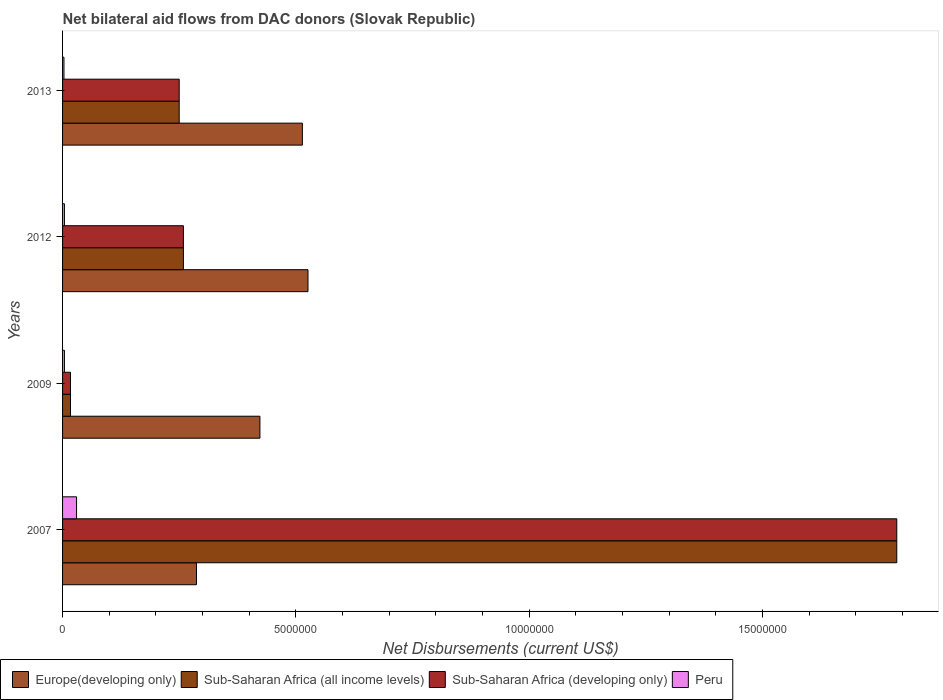How many different coloured bars are there?
Give a very brief answer. 4. Are the number of bars per tick equal to the number of legend labels?
Provide a succinct answer. Yes. Are the number of bars on each tick of the Y-axis equal?
Offer a very short reply. Yes. How many bars are there on the 4th tick from the bottom?
Offer a very short reply. 4. What is the label of the 1st group of bars from the top?
Your response must be concise. 2013. In how many cases, is the number of bars for a given year not equal to the number of legend labels?
Make the answer very short. 0. What is the net bilateral aid flows in Sub-Saharan Africa (developing only) in 2013?
Keep it short and to the point. 2.50e+06. Across all years, what is the minimum net bilateral aid flows in Sub-Saharan Africa (all income levels)?
Make the answer very short. 1.70e+05. In which year was the net bilateral aid flows in Sub-Saharan Africa (developing only) minimum?
Offer a terse response. 2009. What is the difference between the net bilateral aid flows in Sub-Saharan Africa (all income levels) in 2007 and that in 2009?
Give a very brief answer. 1.77e+07. What is the difference between the net bilateral aid flows in Sub-Saharan Africa (developing only) in 2009 and the net bilateral aid flows in Europe(developing only) in 2012?
Provide a short and direct response. -5.09e+06. What is the average net bilateral aid flows in Sub-Saharan Africa (all income levels) per year?
Provide a succinct answer. 5.78e+06. In the year 2012, what is the difference between the net bilateral aid flows in Europe(developing only) and net bilateral aid flows in Sub-Saharan Africa (developing only)?
Ensure brevity in your answer.  2.67e+06. In how many years, is the net bilateral aid flows in Europe(developing only) greater than 10000000 US$?
Ensure brevity in your answer.  0. What is the ratio of the net bilateral aid flows in Peru in 2012 to that in 2013?
Your response must be concise. 1.33. Is the difference between the net bilateral aid flows in Europe(developing only) in 2009 and 2012 greater than the difference between the net bilateral aid flows in Sub-Saharan Africa (developing only) in 2009 and 2012?
Provide a short and direct response. Yes. What is the difference between the highest and the second highest net bilateral aid flows in Sub-Saharan Africa (developing only)?
Your answer should be compact. 1.53e+07. What does the 3rd bar from the top in 2007 represents?
Your response must be concise. Sub-Saharan Africa (all income levels). What does the 2nd bar from the bottom in 2012 represents?
Offer a terse response. Sub-Saharan Africa (all income levels). Is it the case that in every year, the sum of the net bilateral aid flows in Sub-Saharan Africa (developing only) and net bilateral aid flows in Europe(developing only) is greater than the net bilateral aid flows in Sub-Saharan Africa (all income levels)?
Offer a terse response. Yes. Are all the bars in the graph horizontal?
Your answer should be very brief. Yes. What is the difference between two consecutive major ticks on the X-axis?
Provide a succinct answer. 5.00e+06. Where does the legend appear in the graph?
Your response must be concise. Bottom left. How many legend labels are there?
Your answer should be compact. 4. What is the title of the graph?
Your answer should be very brief. Net bilateral aid flows from DAC donors (Slovak Republic). What is the label or title of the X-axis?
Keep it short and to the point. Net Disbursements (current US$). What is the Net Disbursements (current US$) of Europe(developing only) in 2007?
Ensure brevity in your answer.  2.87e+06. What is the Net Disbursements (current US$) of Sub-Saharan Africa (all income levels) in 2007?
Your response must be concise. 1.79e+07. What is the Net Disbursements (current US$) of Sub-Saharan Africa (developing only) in 2007?
Offer a very short reply. 1.79e+07. What is the Net Disbursements (current US$) of Europe(developing only) in 2009?
Provide a succinct answer. 4.23e+06. What is the Net Disbursements (current US$) of Sub-Saharan Africa (all income levels) in 2009?
Make the answer very short. 1.70e+05. What is the Net Disbursements (current US$) in Sub-Saharan Africa (developing only) in 2009?
Your response must be concise. 1.70e+05. What is the Net Disbursements (current US$) of Peru in 2009?
Keep it short and to the point. 4.00e+04. What is the Net Disbursements (current US$) of Europe(developing only) in 2012?
Offer a very short reply. 5.26e+06. What is the Net Disbursements (current US$) in Sub-Saharan Africa (all income levels) in 2012?
Your answer should be compact. 2.59e+06. What is the Net Disbursements (current US$) in Sub-Saharan Africa (developing only) in 2012?
Offer a very short reply. 2.59e+06. What is the Net Disbursements (current US$) of Peru in 2012?
Make the answer very short. 4.00e+04. What is the Net Disbursements (current US$) of Europe(developing only) in 2013?
Keep it short and to the point. 5.14e+06. What is the Net Disbursements (current US$) in Sub-Saharan Africa (all income levels) in 2013?
Give a very brief answer. 2.50e+06. What is the Net Disbursements (current US$) of Sub-Saharan Africa (developing only) in 2013?
Your response must be concise. 2.50e+06. Across all years, what is the maximum Net Disbursements (current US$) in Europe(developing only)?
Your response must be concise. 5.26e+06. Across all years, what is the maximum Net Disbursements (current US$) of Sub-Saharan Africa (all income levels)?
Provide a short and direct response. 1.79e+07. Across all years, what is the maximum Net Disbursements (current US$) in Sub-Saharan Africa (developing only)?
Provide a short and direct response. 1.79e+07. Across all years, what is the maximum Net Disbursements (current US$) in Peru?
Give a very brief answer. 3.00e+05. Across all years, what is the minimum Net Disbursements (current US$) of Europe(developing only)?
Offer a terse response. 2.87e+06. Across all years, what is the minimum Net Disbursements (current US$) of Sub-Saharan Africa (all income levels)?
Ensure brevity in your answer.  1.70e+05. What is the total Net Disbursements (current US$) of Europe(developing only) in the graph?
Provide a short and direct response. 1.75e+07. What is the total Net Disbursements (current US$) in Sub-Saharan Africa (all income levels) in the graph?
Offer a very short reply. 2.31e+07. What is the total Net Disbursements (current US$) of Sub-Saharan Africa (developing only) in the graph?
Make the answer very short. 2.31e+07. What is the difference between the Net Disbursements (current US$) of Europe(developing only) in 2007 and that in 2009?
Make the answer very short. -1.36e+06. What is the difference between the Net Disbursements (current US$) of Sub-Saharan Africa (all income levels) in 2007 and that in 2009?
Ensure brevity in your answer.  1.77e+07. What is the difference between the Net Disbursements (current US$) of Sub-Saharan Africa (developing only) in 2007 and that in 2009?
Ensure brevity in your answer.  1.77e+07. What is the difference between the Net Disbursements (current US$) in Europe(developing only) in 2007 and that in 2012?
Provide a succinct answer. -2.39e+06. What is the difference between the Net Disbursements (current US$) in Sub-Saharan Africa (all income levels) in 2007 and that in 2012?
Keep it short and to the point. 1.53e+07. What is the difference between the Net Disbursements (current US$) in Sub-Saharan Africa (developing only) in 2007 and that in 2012?
Provide a succinct answer. 1.53e+07. What is the difference between the Net Disbursements (current US$) in Europe(developing only) in 2007 and that in 2013?
Your answer should be very brief. -2.27e+06. What is the difference between the Net Disbursements (current US$) in Sub-Saharan Africa (all income levels) in 2007 and that in 2013?
Give a very brief answer. 1.54e+07. What is the difference between the Net Disbursements (current US$) in Sub-Saharan Africa (developing only) in 2007 and that in 2013?
Your response must be concise. 1.54e+07. What is the difference between the Net Disbursements (current US$) of Peru in 2007 and that in 2013?
Ensure brevity in your answer.  2.70e+05. What is the difference between the Net Disbursements (current US$) in Europe(developing only) in 2009 and that in 2012?
Your answer should be compact. -1.03e+06. What is the difference between the Net Disbursements (current US$) in Sub-Saharan Africa (all income levels) in 2009 and that in 2012?
Your answer should be very brief. -2.42e+06. What is the difference between the Net Disbursements (current US$) of Sub-Saharan Africa (developing only) in 2009 and that in 2012?
Keep it short and to the point. -2.42e+06. What is the difference between the Net Disbursements (current US$) of Europe(developing only) in 2009 and that in 2013?
Ensure brevity in your answer.  -9.10e+05. What is the difference between the Net Disbursements (current US$) in Sub-Saharan Africa (all income levels) in 2009 and that in 2013?
Give a very brief answer. -2.33e+06. What is the difference between the Net Disbursements (current US$) of Sub-Saharan Africa (developing only) in 2009 and that in 2013?
Give a very brief answer. -2.33e+06. What is the difference between the Net Disbursements (current US$) of Peru in 2009 and that in 2013?
Your answer should be compact. 10000. What is the difference between the Net Disbursements (current US$) in Europe(developing only) in 2012 and that in 2013?
Provide a succinct answer. 1.20e+05. What is the difference between the Net Disbursements (current US$) of Sub-Saharan Africa (all income levels) in 2012 and that in 2013?
Give a very brief answer. 9.00e+04. What is the difference between the Net Disbursements (current US$) of Sub-Saharan Africa (developing only) in 2012 and that in 2013?
Your answer should be very brief. 9.00e+04. What is the difference between the Net Disbursements (current US$) in Peru in 2012 and that in 2013?
Keep it short and to the point. 10000. What is the difference between the Net Disbursements (current US$) in Europe(developing only) in 2007 and the Net Disbursements (current US$) in Sub-Saharan Africa (all income levels) in 2009?
Your answer should be very brief. 2.70e+06. What is the difference between the Net Disbursements (current US$) in Europe(developing only) in 2007 and the Net Disbursements (current US$) in Sub-Saharan Africa (developing only) in 2009?
Give a very brief answer. 2.70e+06. What is the difference between the Net Disbursements (current US$) in Europe(developing only) in 2007 and the Net Disbursements (current US$) in Peru in 2009?
Your answer should be compact. 2.83e+06. What is the difference between the Net Disbursements (current US$) of Sub-Saharan Africa (all income levels) in 2007 and the Net Disbursements (current US$) of Sub-Saharan Africa (developing only) in 2009?
Offer a terse response. 1.77e+07. What is the difference between the Net Disbursements (current US$) in Sub-Saharan Africa (all income levels) in 2007 and the Net Disbursements (current US$) in Peru in 2009?
Offer a terse response. 1.78e+07. What is the difference between the Net Disbursements (current US$) in Sub-Saharan Africa (developing only) in 2007 and the Net Disbursements (current US$) in Peru in 2009?
Offer a terse response. 1.78e+07. What is the difference between the Net Disbursements (current US$) of Europe(developing only) in 2007 and the Net Disbursements (current US$) of Sub-Saharan Africa (all income levels) in 2012?
Keep it short and to the point. 2.80e+05. What is the difference between the Net Disbursements (current US$) of Europe(developing only) in 2007 and the Net Disbursements (current US$) of Sub-Saharan Africa (developing only) in 2012?
Provide a succinct answer. 2.80e+05. What is the difference between the Net Disbursements (current US$) of Europe(developing only) in 2007 and the Net Disbursements (current US$) of Peru in 2012?
Your response must be concise. 2.83e+06. What is the difference between the Net Disbursements (current US$) in Sub-Saharan Africa (all income levels) in 2007 and the Net Disbursements (current US$) in Sub-Saharan Africa (developing only) in 2012?
Give a very brief answer. 1.53e+07. What is the difference between the Net Disbursements (current US$) in Sub-Saharan Africa (all income levels) in 2007 and the Net Disbursements (current US$) in Peru in 2012?
Provide a succinct answer. 1.78e+07. What is the difference between the Net Disbursements (current US$) in Sub-Saharan Africa (developing only) in 2007 and the Net Disbursements (current US$) in Peru in 2012?
Provide a short and direct response. 1.78e+07. What is the difference between the Net Disbursements (current US$) of Europe(developing only) in 2007 and the Net Disbursements (current US$) of Sub-Saharan Africa (developing only) in 2013?
Give a very brief answer. 3.70e+05. What is the difference between the Net Disbursements (current US$) in Europe(developing only) in 2007 and the Net Disbursements (current US$) in Peru in 2013?
Your answer should be very brief. 2.84e+06. What is the difference between the Net Disbursements (current US$) of Sub-Saharan Africa (all income levels) in 2007 and the Net Disbursements (current US$) of Sub-Saharan Africa (developing only) in 2013?
Your answer should be compact. 1.54e+07. What is the difference between the Net Disbursements (current US$) of Sub-Saharan Africa (all income levels) in 2007 and the Net Disbursements (current US$) of Peru in 2013?
Give a very brief answer. 1.78e+07. What is the difference between the Net Disbursements (current US$) of Sub-Saharan Africa (developing only) in 2007 and the Net Disbursements (current US$) of Peru in 2013?
Your answer should be compact. 1.78e+07. What is the difference between the Net Disbursements (current US$) of Europe(developing only) in 2009 and the Net Disbursements (current US$) of Sub-Saharan Africa (all income levels) in 2012?
Offer a very short reply. 1.64e+06. What is the difference between the Net Disbursements (current US$) of Europe(developing only) in 2009 and the Net Disbursements (current US$) of Sub-Saharan Africa (developing only) in 2012?
Offer a very short reply. 1.64e+06. What is the difference between the Net Disbursements (current US$) of Europe(developing only) in 2009 and the Net Disbursements (current US$) of Peru in 2012?
Your answer should be very brief. 4.19e+06. What is the difference between the Net Disbursements (current US$) in Sub-Saharan Africa (all income levels) in 2009 and the Net Disbursements (current US$) in Sub-Saharan Africa (developing only) in 2012?
Make the answer very short. -2.42e+06. What is the difference between the Net Disbursements (current US$) in Sub-Saharan Africa (developing only) in 2009 and the Net Disbursements (current US$) in Peru in 2012?
Offer a very short reply. 1.30e+05. What is the difference between the Net Disbursements (current US$) of Europe(developing only) in 2009 and the Net Disbursements (current US$) of Sub-Saharan Africa (all income levels) in 2013?
Offer a very short reply. 1.73e+06. What is the difference between the Net Disbursements (current US$) of Europe(developing only) in 2009 and the Net Disbursements (current US$) of Sub-Saharan Africa (developing only) in 2013?
Offer a very short reply. 1.73e+06. What is the difference between the Net Disbursements (current US$) in Europe(developing only) in 2009 and the Net Disbursements (current US$) in Peru in 2013?
Offer a very short reply. 4.20e+06. What is the difference between the Net Disbursements (current US$) in Sub-Saharan Africa (all income levels) in 2009 and the Net Disbursements (current US$) in Sub-Saharan Africa (developing only) in 2013?
Ensure brevity in your answer.  -2.33e+06. What is the difference between the Net Disbursements (current US$) in Sub-Saharan Africa (developing only) in 2009 and the Net Disbursements (current US$) in Peru in 2013?
Ensure brevity in your answer.  1.40e+05. What is the difference between the Net Disbursements (current US$) in Europe(developing only) in 2012 and the Net Disbursements (current US$) in Sub-Saharan Africa (all income levels) in 2013?
Keep it short and to the point. 2.76e+06. What is the difference between the Net Disbursements (current US$) of Europe(developing only) in 2012 and the Net Disbursements (current US$) of Sub-Saharan Africa (developing only) in 2013?
Give a very brief answer. 2.76e+06. What is the difference between the Net Disbursements (current US$) of Europe(developing only) in 2012 and the Net Disbursements (current US$) of Peru in 2013?
Your answer should be compact. 5.23e+06. What is the difference between the Net Disbursements (current US$) of Sub-Saharan Africa (all income levels) in 2012 and the Net Disbursements (current US$) of Peru in 2013?
Make the answer very short. 2.56e+06. What is the difference between the Net Disbursements (current US$) of Sub-Saharan Africa (developing only) in 2012 and the Net Disbursements (current US$) of Peru in 2013?
Provide a succinct answer. 2.56e+06. What is the average Net Disbursements (current US$) in Europe(developing only) per year?
Provide a succinct answer. 4.38e+06. What is the average Net Disbursements (current US$) in Sub-Saharan Africa (all income levels) per year?
Make the answer very short. 5.78e+06. What is the average Net Disbursements (current US$) of Sub-Saharan Africa (developing only) per year?
Ensure brevity in your answer.  5.78e+06. What is the average Net Disbursements (current US$) in Peru per year?
Give a very brief answer. 1.02e+05. In the year 2007, what is the difference between the Net Disbursements (current US$) in Europe(developing only) and Net Disbursements (current US$) in Sub-Saharan Africa (all income levels)?
Offer a terse response. -1.50e+07. In the year 2007, what is the difference between the Net Disbursements (current US$) in Europe(developing only) and Net Disbursements (current US$) in Sub-Saharan Africa (developing only)?
Your answer should be very brief. -1.50e+07. In the year 2007, what is the difference between the Net Disbursements (current US$) in Europe(developing only) and Net Disbursements (current US$) in Peru?
Your answer should be compact. 2.57e+06. In the year 2007, what is the difference between the Net Disbursements (current US$) of Sub-Saharan Africa (all income levels) and Net Disbursements (current US$) of Sub-Saharan Africa (developing only)?
Provide a succinct answer. 0. In the year 2007, what is the difference between the Net Disbursements (current US$) of Sub-Saharan Africa (all income levels) and Net Disbursements (current US$) of Peru?
Provide a succinct answer. 1.76e+07. In the year 2007, what is the difference between the Net Disbursements (current US$) of Sub-Saharan Africa (developing only) and Net Disbursements (current US$) of Peru?
Your answer should be compact. 1.76e+07. In the year 2009, what is the difference between the Net Disbursements (current US$) of Europe(developing only) and Net Disbursements (current US$) of Sub-Saharan Africa (all income levels)?
Make the answer very short. 4.06e+06. In the year 2009, what is the difference between the Net Disbursements (current US$) in Europe(developing only) and Net Disbursements (current US$) in Sub-Saharan Africa (developing only)?
Keep it short and to the point. 4.06e+06. In the year 2009, what is the difference between the Net Disbursements (current US$) of Europe(developing only) and Net Disbursements (current US$) of Peru?
Ensure brevity in your answer.  4.19e+06. In the year 2009, what is the difference between the Net Disbursements (current US$) of Sub-Saharan Africa (all income levels) and Net Disbursements (current US$) of Peru?
Make the answer very short. 1.30e+05. In the year 2009, what is the difference between the Net Disbursements (current US$) of Sub-Saharan Africa (developing only) and Net Disbursements (current US$) of Peru?
Give a very brief answer. 1.30e+05. In the year 2012, what is the difference between the Net Disbursements (current US$) in Europe(developing only) and Net Disbursements (current US$) in Sub-Saharan Africa (all income levels)?
Give a very brief answer. 2.67e+06. In the year 2012, what is the difference between the Net Disbursements (current US$) in Europe(developing only) and Net Disbursements (current US$) in Sub-Saharan Africa (developing only)?
Your answer should be very brief. 2.67e+06. In the year 2012, what is the difference between the Net Disbursements (current US$) in Europe(developing only) and Net Disbursements (current US$) in Peru?
Make the answer very short. 5.22e+06. In the year 2012, what is the difference between the Net Disbursements (current US$) of Sub-Saharan Africa (all income levels) and Net Disbursements (current US$) of Sub-Saharan Africa (developing only)?
Your answer should be compact. 0. In the year 2012, what is the difference between the Net Disbursements (current US$) in Sub-Saharan Africa (all income levels) and Net Disbursements (current US$) in Peru?
Your answer should be compact. 2.55e+06. In the year 2012, what is the difference between the Net Disbursements (current US$) of Sub-Saharan Africa (developing only) and Net Disbursements (current US$) of Peru?
Keep it short and to the point. 2.55e+06. In the year 2013, what is the difference between the Net Disbursements (current US$) of Europe(developing only) and Net Disbursements (current US$) of Sub-Saharan Africa (all income levels)?
Give a very brief answer. 2.64e+06. In the year 2013, what is the difference between the Net Disbursements (current US$) of Europe(developing only) and Net Disbursements (current US$) of Sub-Saharan Africa (developing only)?
Offer a terse response. 2.64e+06. In the year 2013, what is the difference between the Net Disbursements (current US$) of Europe(developing only) and Net Disbursements (current US$) of Peru?
Your answer should be very brief. 5.11e+06. In the year 2013, what is the difference between the Net Disbursements (current US$) of Sub-Saharan Africa (all income levels) and Net Disbursements (current US$) of Peru?
Make the answer very short. 2.47e+06. In the year 2013, what is the difference between the Net Disbursements (current US$) of Sub-Saharan Africa (developing only) and Net Disbursements (current US$) of Peru?
Provide a succinct answer. 2.47e+06. What is the ratio of the Net Disbursements (current US$) of Europe(developing only) in 2007 to that in 2009?
Provide a succinct answer. 0.68. What is the ratio of the Net Disbursements (current US$) of Sub-Saharan Africa (all income levels) in 2007 to that in 2009?
Your answer should be compact. 105.18. What is the ratio of the Net Disbursements (current US$) in Sub-Saharan Africa (developing only) in 2007 to that in 2009?
Keep it short and to the point. 105.18. What is the ratio of the Net Disbursements (current US$) in Europe(developing only) in 2007 to that in 2012?
Your response must be concise. 0.55. What is the ratio of the Net Disbursements (current US$) of Sub-Saharan Africa (all income levels) in 2007 to that in 2012?
Provide a short and direct response. 6.9. What is the ratio of the Net Disbursements (current US$) of Sub-Saharan Africa (developing only) in 2007 to that in 2012?
Provide a short and direct response. 6.9. What is the ratio of the Net Disbursements (current US$) of Europe(developing only) in 2007 to that in 2013?
Offer a very short reply. 0.56. What is the ratio of the Net Disbursements (current US$) of Sub-Saharan Africa (all income levels) in 2007 to that in 2013?
Your answer should be compact. 7.15. What is the ratio of the Net Disbursements (current US$) of Sub-Saharan Africa (developing only) in 2007 to that in 2013?
Your answer should be compact. 7.15. What is the ratio of the Net Disbursements (current US$) in Europe(developing only) in 2009 to that in 2012?
Your response must be concise. 0.8. What is the ratio of the Net Disbursements (current US$) of Sub-Saharan Africa (all income levels) in 2009 to that in 2012?
Make the answer very short. 0.07. What is the ratio of the Net Disbursements (current US$) of Sub-Saharan Africa (developing only) in 2009 to that in 2012?
Your answer should be compact. 0.07. What is the ratio of the Net Disbursements (current US$) of Peru in 2009 to that in 2012?
Provide a succinct answer. 1. What is the ratio of the Net Disbursements (current US$) in Europe(developing only) in 2009 to that in 2013?
Offer a terse response. 0.82. What is the ratio of the Net Disbursements (current US$) of Sub-Saharan Africa (all income levels) in 2009 to that in 2013?
Keep it short and to the point. 0.07. What is the ratio of the Net Disbursements (current US$) in Sub-Saharan Africa (developing only) in 2009 to that in 2013?
Offer a very short reply. 0.07. What is the ratio of the Net Disbursements (current US$) in Peru in 2009 to that in 2013?
Your answer should be compact. 1.33. What is the ratio of the Net Disbursements (current US$) in Europe(developing only) in 2012 to that in 2013?
Provide a succinct answer. 1.02. What is the ratio of the Net Disbursements (current US$) of Sub-Saharan Africa (all income levels) in 2012 to that in 2013?
Your response must be concise. 1.04. What is the ratio of the Net Disbursements (current US$) in Sub-Saharan Africa (developing only) in 2012 to that in 2013?
Keep it short and to the point. 1.04. What is the ratio of the Net Disbursements (current US$) of Peru in 2012 to that in 2013?
Provide a succinct answer. 1.33. What is the difference between the highest and the second highest Net Disbursements (current US$) in Europe(developing only)?
Your answer should be compact. 1.20e+05. What is the difference between the highest and the second highest Net Disbursements (current US$) in Sub-Saharan Africa (all income levels)?
Offer a very short reply. 1.53e+07. What is the difference between the highest and the second highest Net Disbursements (current US$) in Sub-Saharan Africa (developing only)?
Provide a succinct answer. 1.53e+07. What is the difference between the highest and the second highest Net Disbursements (current US$) in Peru?
Provide a short and direct response. 2.60e+05. What is the difference between the highest and the lowest Net Disbursements (current US$) in Europe(developing only)?
Your answer should be compact. 2.39e+06. What is the difference between the highest and the lowest Net Disbursements (current US$) in Sub-Saharan Africa (all income levels)?
Give a very brief answer. 1.77e+07. What is the difference between the highest and the lowest Net Disbursements (current US$) of Sub-Saharan Africa (developing only)?
Give a very brief answer. 1.77e+07. 